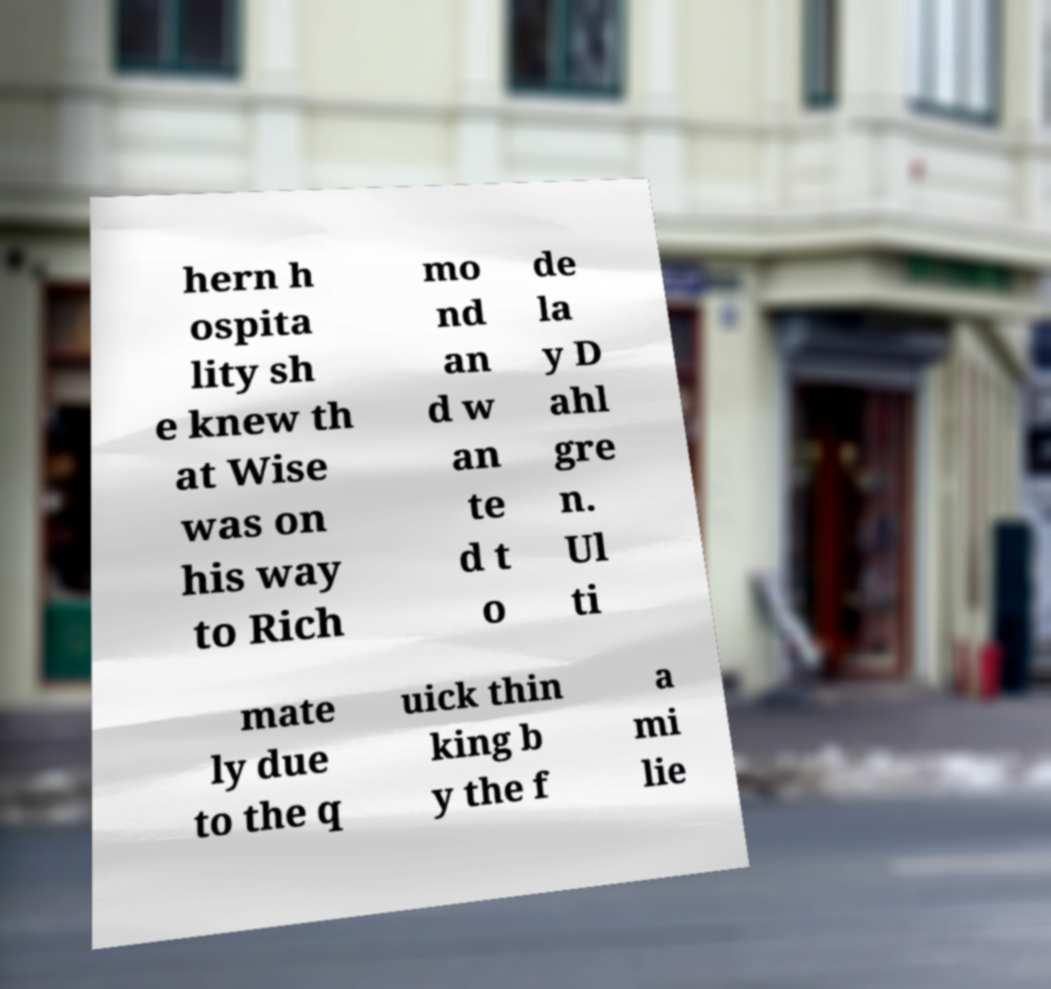Please read and relay the text visible in this image. What does it say? hern h ospita lity sh e knew th at Wise was on his way to Rich mo nd an d w an te d t o de la y D ahl gre n. Ul ti mate ly due to the q uick thin king b y the f a mi lie 